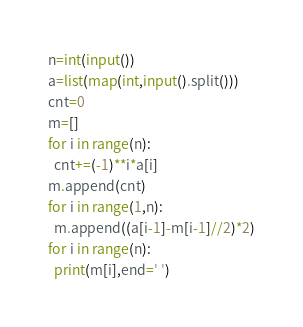<code> <loc_0><loc_0><loc_500><loc_500><_Python_>n=int(input())
a=list(map(int,input().split()))
cnt=0
m=[]
for i in range(n):
  cnt+=(-1)**i*a[i]
m.append(cnt)
for i in range(1,n):
  m.append((a[i-1]-m[i-1]//2)*2)
for i in range(n):
  print(m[i],end=' ')</code> 